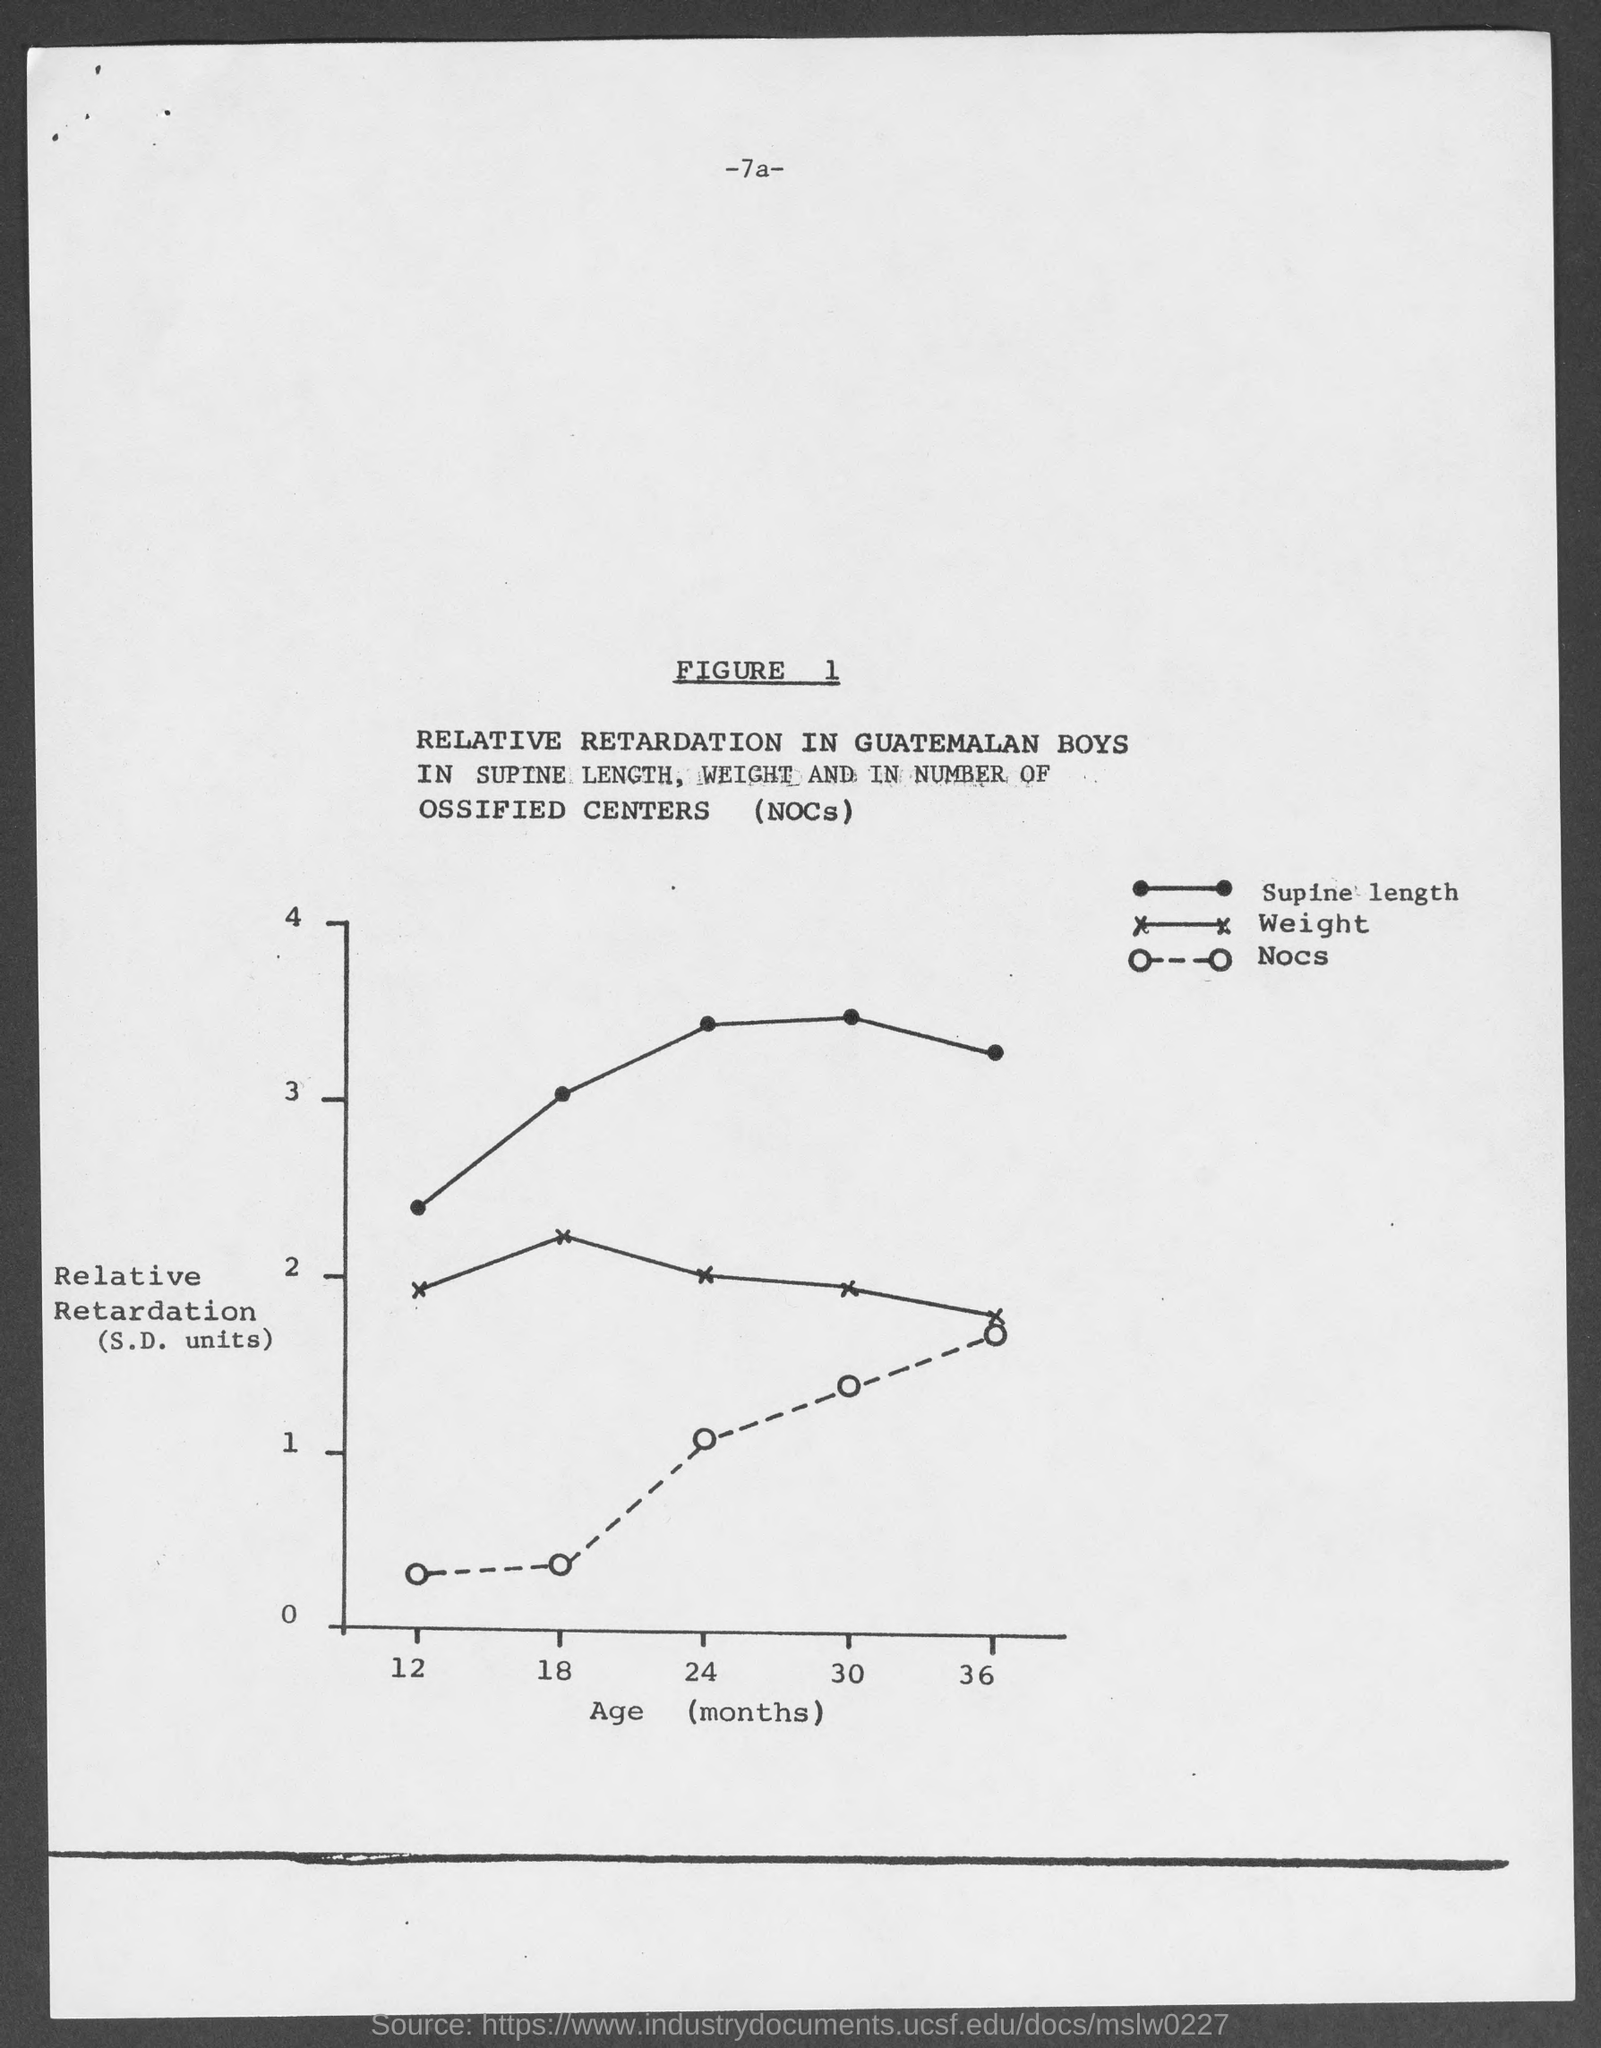What is plotted in the x-axis ?
Provide a short and direct response. Age (months). Dotted line in this graph refers to?
Your response must be concise. Nocs. 